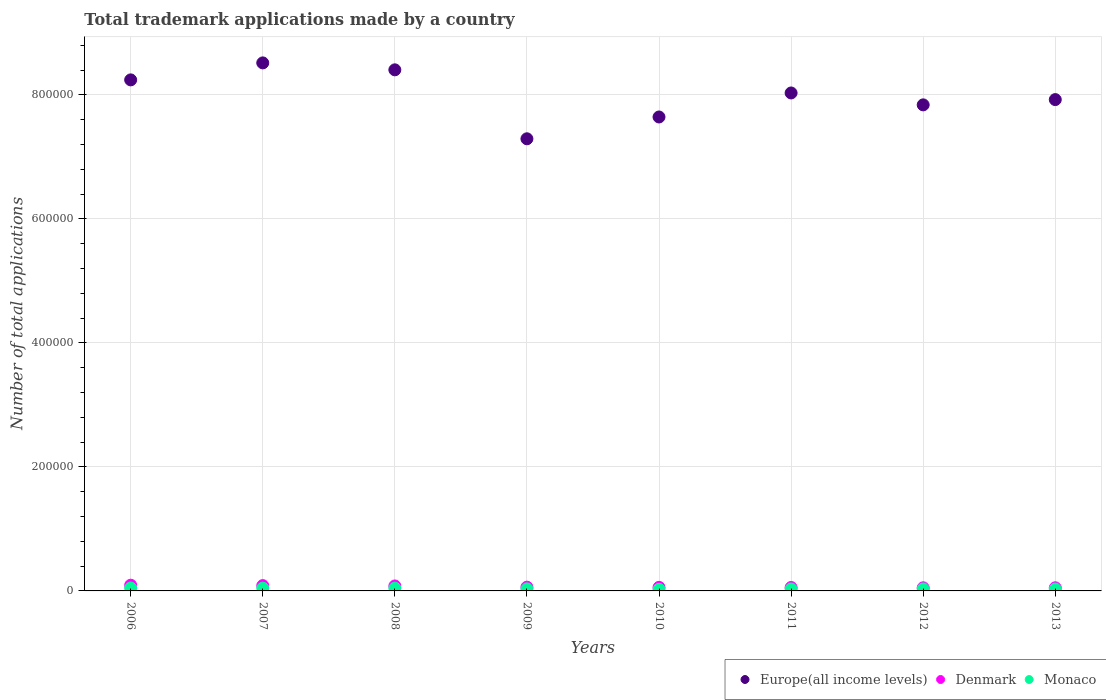How many different coloured dotlines are there?
Offer a very short reply. 3. What is the number of applications made by in Denmark in 2006?
Keep it short and to the point. 9226. Across all years, what is the maximum number of applications made by in Denmark?
Your answer should be compact. 9226. Across all years, what is the minimum number of applications made by in Monaco?
Offer a terse response. 2567. In which year was the number of applications made by in Europe(all income levels) minimum?
Give a very brief answer. 2009. What is the total number of applications made by in Denmark in the graph?
Provide a succinct answer. 5.33e+04. What is the difference between the number of applications made by in Denmark in 2006 and that in 2008?
Your answer should be compact. 1207. What is the difference between the number of applications made by in Denmark in 2006 and the number of applications made by in Europe(all income levels) in 2011?
Your response must be concise. -7.94e+05. What is the average number of applications made by in Monaco per year?
Provide a succinct answer. 3631.5. In the year 2007, what is the difference between the number of applications made by in Denmark and number of applications made by in Monaco?
Ensure brevity in your answer.  4170. In how many years, is the number of applications made by in Europe(all income levels) greater than 760000?
Your response must be concise. 7. What is the ratio of the number of applications made by in Monaco in 2008 to that in 2011?
Your answer should be very brief. 1.39. Is the difference between the number of applications made by in Denmark in 2011 and 2012 greater than the difference between the number of applications made by in Monaco in 2011 and 2012?
Provide a short and direct response. Yes. What is the difference between the highest and the second highest number of applications made by in Monaco?
Give a very brief answer. 175. What is the difference between the highest and the lowest number of applications made by in Europe(all income levels)?
Your answer should be compact. 1.22e+05. Is it the case that in every year, the sum of the number of applications made by in Europe(all income levels) and number of applications made by in Monaco  is greater than the number of applications made by in Denmark?
Offer a terse response. Yes. Are the values on the major ticks of Y-axis written in scientific E-notation?
Provide a short and direct response. No. Does the graph contain any zero values?
Offer a very short reply. No. Does the graph contain grids?
Provide a short and direct response. Yes. How many legend labels are there?
Your answer should be very brief. 3. What is the title of the graph?
Provide a succinct answer. Total trademark applications made by a country. What is the label or title of the X-axis?
Ensure brevity in your answer.  Years. What is the label or title of the Y-axis?
Provide a succinct answer. Number of total applications. What is the Number of total applications in Europe(all income levels) in 2006?
Provide a succinct answer. 8.24e+05. What is the Number of total applications of Denmark in 2006?
Offer a terse response. 9226. What is the Number of total applications in Monaco in 2006?
Provide a short and direct response. 4649. What is the Number of total applications in Europe(all income levels) in 2007?
Make the answer very short. 8.52e+05. What is the Number of total applications in Denmark in 2007?
Make the answer very short. 8583. What is the Number of total applications of Monaco in 2007?
Offer a terse response. 4413. What is the Number of total applications of Europe(all income levels) in 2008?
Provide a succinct answer. 8.40e+05. What is the Number of total applications in Denmark in 2008?
Your answer should be very brief. 8019. What is the Number of total applications of Monaco in 2008?
Offer a terse response. 4474. What is the Number of total applications of Europe(all income levels) in 2009?
Make the answer very short. 7.29e+05. What is the Number of total applications of Denmark in 2009?
Your answer should be very brief. 6075. What is the Number of total applications in Monaco in 2009?
Give a very brief answer. 3324. What is the Number of total applications in Europe(all income levels) in 2010?
Your answer should be compact. 7.64e+05. What is the Number of total applications of Denmark in 2010?
Ensure brevity in your answer.  5750. What is the Number of total applications in Monaco in 2010?
Provide a short and direct response. 2567. What is the Number of total applications of Europe(all income levels) in 2011?
Provide a succinct answer. 8.03e+05. What is the Number of total applications of Denmark in 2011?
Your response must be concise. 5549. What is the Number of total applications in Monaco in 2011?
Make the answer very short. 3212. What is the Number of total applications in Europe(all income levels) in 2012?
Provide a short and direct response. 7.84e+05. What is the Number of total applications in Denmark in 2012?
Give a very brief answer. 5032. What is the Number of total applications in Monaco in 2012?
Your answer should be very brief. 3264. What is the Number of total applications of Europe(all income levels) in 2013?
Provide a succinct answer. 7.92e+05. What is the Number of total applications of Denmark in 2013?
Provide a short and direct response. 5054. What is the Number of total applications of Monaco in 2013?
Keep it short and to the point. 3149. Across all years, what is the maximum Number of total applications in Europe(all income levels)?
Your answer should be compact. 8.52e+05. Across all years, what is the maximum Number of total applications in Denmark?
Make the answer very short. 9226. Across all years, what is the maximum Number of total applications of Monaco?
Keep it short and to the point. 4649. Across all years, what is the minimum Number of total applications in Europe(all income levels)?
Give a very brief answer. 7.29e+05. Across all years, what is the minimum Number of total applications of Denmark?
Make the answer very short. 5032. Across all years, what is the minimum Number of total applications in Monaco?
Your response must be concise. 2567. What is the total Number of total applications in Europe(all income levels) in the graph?
Your answer should be compact. 6.39e+06. What is the total Number of total applications in Denmark in the graph?
Give a very brief answer. 5.33e+04. What is the total Number of total applications in Monaco in the graph?
Give a very brief answer. 2.91e+04. What is the difference between the Number of total applications of Europe(all income levels) in 2006 and that in 2007?
Your answer should be compact. -2.74e+04. What is the difference between the Number of total applications of Denmark in 2006 and that in 2007?
Your answer should be very brief. 643. What is the difference between the Number of total applications of Monaco in 2006 and that in 2007?
Keep it short and to the point. 236. What is the difference between the Number of total applications in Europe(all income levels) in 2006 and that in 2008?
Provide a succinct answer. -1.62e+04. What is the difference between the Number of total applications in Denmark in 2006 and that in 2008?
Offer a very short reply. 1207. What is the difference between the Number of total applications in Monaco in 2006 and that in 2008?
Offer a very short reply. 175. What is the difference between the Number of total applications of Europe(all income levels) in 2006 and that in 2009?
Provide a short and direct response. 9.50e+04. What is the difference between the Number of total applications of Denmark in 2006 and that in 2009?
Ensure brevity in your answer.  3151. What is the difference between the Number of total applications of Monaco in 2006 and that in 2009?
Offer a very short reply. 1325. What is the difference between the Number of total applications in Europe(all income levels) in 2006 and that in 2010?
Your response must be concise. 5.98e+04. What is the difference between the Number of total applications in Denmark in 2006 and that in 2010?
Keep it short and to the point. 3476. What is the difference between the Number of total applications in Monaco in 2006 and that in 2010?
Provide a succinct answer. 2082. What is the difference between the Number of total applications in Europe(all income levels) in 2006 and that in 2011?
Give a very brief answer. 2.11e+04. What is the difference between the Number of total applications of Denmark in 2006 and that in 2011?
Ensure brevity in your answer.  3677. What is the difference between the Number of total applications in Monaco in 2006 and that in 2011?
Provide a succinct answer. 1437. What is the difference between the Number of total applications in Europe(all income levels) in 2006 and that in 2012?
Your answer should be compact. 4.03e+04. What is the difference between the Number of total applications in Denmark in 2006 and that in 2012?
Give a very brief answer. 4194. What is the difference between the Number of total applications of Monaco in 2006 and that in 2012?
Give a very brief answer. 1385. What is the difference between the Number of total applications in Europe(all income levels) in 2006 and that in 2013?
Offer a very short reply. 3.18e+04. What is the difference between the Number of total applications of Denmark in 2006 and that in 2013?
Your answer should be compact. 4172. What is the difference between the Number of total applications of Monaco in 2006 and that in 2013?
Keep it short and to the point. 1500. What is the difference between the Number of total applications of Europe(all income levels) in 2007 and that in 2008?
Your response must be concise. 1.12e+04. What is the difference between the Number of total applications of Denmark in 2007 and that in 2008?
Offer a terse response. 564. What is the difference between the Number of total applications in Monaco in 2007 and that in 2008?
Make the answer very short. -61. What is the difference between the Number of total applications in Europe(all income levels) in 2007 and that in 2009?
Provide a succinct answer. 1.22e+05. What is the difference between the Number of total applications in Denmark in 2007 and that in 2009?
Make the answer very short. 2508. What is the difference between the Number of total applications of Monaco in 2007 and that in 2009?
Provide a short and direct response. 1089. What is the difference between the Number of total applications of Europe(all income levels) in 2007 and that in 2010?
Your answer should be very brief. 8.72e+04. What is the difference between the Number of total applications of Denmark in 2007 and that in 2010?
Make the answer very short. 2833. What is the difference between the Number of total applications in Monaco in 2007 and that in 2010?
Provide a succinct answer. 1846. What is the difference between the Number of total applications in Europe(all income levels) in 2007 and that in 2011?
Ensure brevity in your answer.  4.85e+04. What is the difference between the Number of total applications of Denmark in 2007 and that in 2011?
Your response must be concise. 3034. What is the difference between the Number of total applications of Monaco in 2007 and that in 2011?
Your response must be concise. 1201. What is the difference between the Number of total applications in Europe(all income levels) in 2007 and that in 2012?
Your answer should be very brief. 6.77e+04. What is the difference between the Number of total applications in Denmark in 2007 and that in 2012?
Keep it short and to the point. 3551. What is the difference between the Number of total applications of Monaco in 2007 and that in 2012?
Provide a short and direct response. 1149. What is the difference between the Number of total applications of Europe(all income levels) in 2007 and that in 2013?
Keep it short and to the point. 5.92e+04. What is the difference between the Number of total applications in Denmark in 2007 and that in 2013?
Provide a succinct answer. 3529. What is the difference between the Number of total applications in Monaco in 2007 and that in 2013?
Provide a succinct answer. 1264. What is the difference between the Number of total applications of Europe(all income levels) in 2008 and that in 2009?
Your answer should be compact. 1.11e+05. What is the difference between the Number of total applications in Denmark in 2008 and that in 2009?
Give a very brief answer. 1944. What is the difference between the Number of total applications in Monaco in 2008 and that in 2009?
Make the answer very short. 1150. What is the difference between the Number of total applications of Europe(all income levels) in 2008 and that in 2010?
Give a very brief answer. 7.60e+04. What is the difference between the Number of total applications in Denmark in 2008 and that in 2010?
Offer a terse response. 2269. What is the difference between the Number of total applications of Monaco in 2008 and that in 2010?
Your answer should be compact. 1907. What is the difference between the Number of total applications in Europe(all income levels) in 2008 and that in 2011?
Provide a short and direct response. 3.73e+04. What is the difference between the Number of total applications of Denmark in 2008 and that in 2011?
Provide a short and direct response. 2470. What is the difference between the Number of total applications in Monaco in 2008 and that in 2011?
Give a very brief answer. 1262. What is the difference between the Number of total applications in Europe(all income levels) in 2008 and that in 2012?
Your answer should be very brief. 5.65e+04. What is the difference between the Number of total applications in Denmark in 2008 and that in 2012?
Make the answer very short. 2987. What is the difference between the Number of total applications of Monaco in 2008 and that in 2012?
Offer a terse response. 1210. What is the difference between the Number of total applications in Europe(all income levels) in 2008 and that in 2013?
Keep it short and to the point. 4.80e+04. What is the difference between the Number of total applications in Denmark in 2008 and that in 2013?
Offer a very short reply. 2965. What is the difference between the Number of total applications in Monaco in 2008 and that in 2013?
Provide a succinct answer. 1325. What is the difference between the Number of total applications in Europe(all income levels) in 2009 and that in 2010?
Ensure brevity in your answer.  -3.52e+04. What is the difference between the Number of total applications in Denmark in 2009 and that in 2010?
Keep it short and to the point. 325. What is the difference between the Number of total applications of Monaco in 2009 and that in 2010?
Ensure brevity in your answer.  757. What is the difference between the Number of total applications in Europe(all income levels) in 2009 and that in 2011?
Your answer should be very brief. -7.39e+04. What is the difference between the Number of total applications of Denmark in 2009 and that in 2011?
Give a very brief answer. 526. What is the difference between the Number of total applications in Monaco in 2009 and that in 2011?
Your response must be concise. 112. What is the difference between the Number of total applications in Europe(all income levels) in 2009 and that in 2012?
Your answer should be very brief. -5.47e+04. What is the difference between the Number of total applications of Denmark in 2009 and that in 2012?
Offer a terse response. 1043. What is the difference between the Number of total applications in Monaco in 2009 and that in 2012?
Make the answer very short. 60. What is the difference between the Number of total applications in Europe(all income levels) in 2009 and that in 2013?
Ensure brevity in your answer.  -6.32e+04. What is the difference between the Number of total applications in Denmark in 2009 and that in 2013?
Keep it short and to the point. 1021. What is the difference between the Number of total applications in Monaco in 2009 and that in 2013?
Your answer should be very brief. 175. What is the difference between the Number of total applications of Europe(all income levels) in 2010 and that in 2011?
Your answer should be very brief. -3.87e+04. What is the difference between the Number of total applications in Denmark in 2010 and that in 2011?
Provide a short and direct response. 201. What is the difference between the Number of total applications in Monaco in 2010 and that in 2011?
Make the answer very short. -645. What is the difference between the Number of total applications in Europe(all income levels) in 2010 and that in 2012?
Keep it short and to the point. -1.95e+04. What is the difference between the Number of total applications of Denmark in 2010 and that in 2012?
Offer a very short reply. 718. What is the difference between the Number of total applications of Monaco in 2010 and that in 2012?
Provide a succinct answer. -697. What is the difference between the Number of total applications of Europe(all income levels) in 2010 and that in 2013?
Ensure brevity in your answer.  -2.80e+04. What is the difference between the Number of total applications in Denmark in 2010 and that in 2013?
Give a very brief answer. 696. What is the difference between the Number of total applications of Monaco in 2010 and that in 2013?
Make the answer very short. -582. What is the difference between the Number of total applications of Europe(all income levels) in 2011 and that in 2012?
Give a very brief answer. 1.92e+04. What is the difference between the Number of total applications of Denmark in 2011 and that in 2012?
Ensure brevity in your answer.  517. What is the difference between the Number of total applications in Monaco in 2011 and that in 2012?
Provide a succinct answer. -52. What is the difference between the Number of total applications in Europe(all income levels) in 2011 and that in 2013?
Give a very brief answer. 1.07e+04. What is the difference between the Number of total applications in Denmark in 2011 and that in 2013?
Give a very brief answer. 495. What is the difference between the Number of total applications in Europe(all income levels) in 2012 and that in 2013?
Ensure brevity in your answer.  -8486. What is the difference between the Number of total applications of Denmark in 2012 and that in 2013?
Make the answer very short. -22. What is the difference between the Number of total applications in Monaco in 2012 and that in 2013?
Ensure brevity in your answer.  115. What is the difference between the Number of total applications in Europe(all income levels) in 2006 and the Number of total applications in Denmark in 2007?
Your answer should be very brief. 8.16e+05. What is the difference between the Number of total applications of Europe(all income levels) in 2006 and the Number of total applications of Monaco in 2007?
Offer a very short reply. 8.20e+05. What is the difference between the Number of total applications of Denmark in 2006 and the Number of total applications of Monaco in 2007?
Make the answer very short. 4813. What is the difference between the Number of total applications in Europe(all income levels) in 2006 and the Number of total applications in Denmark in 2008?
Offer a very short reply. 8.16e+05. What is the difference between the Number of total applications of Europe(all income levels) in 2006 and the Number of total applications of Monaco in 2008?
Give a very brief answer. 8.20e+05. What is the difference between the Number of total applications in Denmark in 2006 and the Number of total applications in Monaco in 2008?
Ensure brevity in your answer.  4752. What is the difference between the Number of total applications in Europe(all income levels) in 2006 and the Number of total applications in Denmark in 2009?
Offer a very short reply. 8.18e+05. What is the difference between the Number of total applications of Europe(all income levels) in 2006 and the Number of total applications of Monaco in 2009?
Keep it short and to the point. 8.21e+05. What is the difference between the Number of total applications of Denmark in 2006 and the Number of total applications of Monaco in 2009?
Provide a short and direct response. 5902. What is the difference between the Number of total applications in Europe(all income levels) in 2006 and the Number of total applications in Denmark in 2010?
Offer a very short reply. 8.19e+05. What is the difference between the Number of total applications of Europe(all income levels) in 2006 and the Number of total applications of Monaco in 2010?
Make the answer very short. 8.22e+05. What is the difference between the Number of total applications of Denmark in 2006 and the Number of total applications of Monaco in 2010?
Provide a succinct answer. 6659. What is the difference between the Number of total applications of Europe(all income levels) in 2006 and the Number of total applications of Denmark in 2011?
Your answer should be compact. 8.19e+05. What is the difference between the Number of total applications of Europe(all income levels) in 2006 and the Number of total applications of Monaco in 2011?
Offer a very short reply. 8.21e+05. What is the difference between the Number of total applications in Denmark in 2006 and the Number of total applications in Monaco in 2011?
Provide a succinct answer. 6014. What is the difference between the Number of total applications in Europe(all income levels) in 2006 and the Number of total applications in Denmark in 2012?
Provide a short and direct response. 8.19e+05. What is the difference between the Number of total applications in Europe(all income levels) in 2006 and the Number of total applications in Monaco in 2012?
Your response must be concise. 8.21e+05. What is the difference between the Number of total applications in Denmark in 2006 and the Number of total applications in Monaco in 2012?
Offer a terse response. 5962. What is the difference between the Number of total applications in Europe(all income levels) in 2006 and the Number of total applications in Denmark in 2013?
Make the answer very short. 8.19e+05. What is the difference between the Number of total applications of Europe(all income levels) in 2006 and the Number of total applications of Monaco in 2013?
Keep it short and to the point. 8.21e+05. What is the difference between the Number of total applications of Denmark in 2006 and the Number of total applications of Monaco in 2013?
Ensure brevity in your answer.  6077. What is the difference between the Number of total applications of Europe(all income levels) in 2007 and the Number of total applications of Denmark in 2008?
Offer a very short reply. 8.44e+05. What is the difference between the Number of total applications in Europe(all income levels) in 2007 and the Number of total applications in Monaco in 2008?
Your answer should be compact. 8.47e+05. What is the difference between the Number of total applications of Denmark in 2007 and the Number of total applications of Monaco in 2008?
Give a very brief answer. 4109. What is the difference between the Number of total applications of Europe(all income levels) in 2007 and the Number of total applications of Denmark in 2009?
Offer a very short reply. 8.46e+05. What is the difference between the Number of total applications of Europe(all income levels) in 2007 and the Number of total applications of Monaco in 2009?
Your answer should be compact. 8.48e+05. What is the difference between the Number of total applications of Denmark in 2007 and the Number of total applications of Monaco in 2009?
Your answer should be very brief. 5259. What is the difference between the Number of total applications of Europe(all income levels) in 2007 and the Number of total applications of Denmark in 2010?
Make the answer very short. 8.46e+05. What is the difference between the Number of total applications in Europe(all income levels) in 2007 and the Number of total applications in Monaco in 2010?
Your answer should be compact. 8.49e+05. What is the difference between the Number of total applications in Denmark in 2007 and the Number of total applications in Monaco in 2010?
Keep it short and to the point. 6016. What is the difference between the Number of total applications in Europe(all income levels) in 2007 and the Number of total applications in Denmark in 2011?
Make the answer very short. 8.46e+05. What is the difference between the Number of total applications in Europe(all income levels) in 2007 and the Number of total applications in Monaco in 2011?
Give a very brief answer. 8.48e+05. What is the difference between the Number of total applications in Denmark in 2007 and the Number of total applications in Monaco in 2011?
Make the answer very short. 5371. What is the difference between the Number of total applications in Europe(all income levels) in 2007 and the Number of total applications in Denmark in 2012?
Your answer should be compact. 8.47e+05. What is the difference between the Number of total applications of Europe(all income levels) in 2007 and the Number of total applications of Monaco in 2012?
Make the answer very short. 8.48e+05. What is the difference between the Number of total applications of Denmark in 2007 and the Number of total applications of Monaco in 2012?
Your response must be concise. 5319. What is the difference between the Number of total applications of Europe(all income levels) in 2007 and the Number of total applications of Denmark in 2013?
Keep it short and to the point. 8.47e+05. What is the difference between the Number of total applications of Europe(all income levels) in 2007 and the Number of total applications of Monaco in 2013?
Provide a succinct answer. 8.49e+05. What is the difference between the Number of total applications in Denmark in 2007 and the Number of total applications in Monaco in 2013?
Provide a short and direct response. 5434. What is the difference between the Number of total applications in Europe(all income levels) in 2008 and the Number of total applications in Denmark in 2009?
Provide a succinct answer. 8.34e+05. What is the difference between the Number of total applications in Europe(all income levels) in 2008 and the Number of total applications in Monaco in 2009?
Ensure brevity in your answer.  8.37e+05. What is the difference between the Number of total applications of Denmark in 2008 and the Number of total applications of Monaco in 2009?
Your answer should be very brief. 4695. What is the difference between the Number of total applications of Europe(all income levels) in 2008 and the Number of total applications of Denmark in 2010?
Your answer should be very brief. 8.35e+05. What is the difference between the Number of total applications of Europe(all income levels) in 2008 and the Number of total applications of Monaco in 2010?
Give a very brief answer. 8.38e+05. What is the difference between the Number of total applications in Denmark in 2008 and the Number of total applications in Monaco in 2010?
Provide a succinct answer. 5452. What is the difference between the Number of total applications of Europe(all income levels) in 2008 and the Number of total applications of Denmark in 2011?
Make the answer very short. 8.35e+05. What is the difference between the Number of total applications in Europe(all income levels) in 2008 and the Number of total applications in Monaco in 2011?
Provide a short and direct response. 8.37e+05. What is the difference between the Number of total applications in Denmark in 2008 and the Number of total applications in Monaco in 2011?
Make the answer very short. 4807. What is the difference between the Number of total applications in Europe(all income levels) in 2008 and the Number of total applications in Denmark in 2012?
Offer a very short reply. 8.35e+05. What is the difference between the Number of total applications in Europe(all income levels) in 2008 and the Number of total applications in Monaco in 2012?
Provide a short and direct response. 8.37e+05. What is the difference between the Number of total applications in Denmark in 2008 and the Number of total applications in Monaco in 2012?
Give a very brief answer. 4755. What is the difference between the Number of total applications of Europe(all income levels) in 2008 and the Number of total applications of Denmark in 2013?
Provide a succinct answer. 8.35e+05. What is the difference between the Number of total applications of Europe(all income levels) in 2008 and the Number of total applications of Monaco in 2013?
Your answer should be very brief. 8.37e+05. What is the difference between the Number of total applications of Denmark in 2008 and the Number of total applications of Monaco in 2013?
Make the answer very short. 4870. What is the difference between the Number of total applications of Europe(all income levels) in 2009 and the Number of total applications of Denmark in 2010?
Provide a short and direct response. 7.24e+05. What is the difference between the Number of total applications in Europe(all income levels) in 2009 and the Number of total applications in Monaco in 2010?
Ensure brevity in your answer.  7.27e+05. What is the difference between the Number of total applications of Denmark in 2009 and the Number of total applications of Monaco in 2010?
Make the answer very short. 3508. What is the difference between the Number of total applications of Europe(all income levels) in 2009 and the Number of total applications of Denmark in 2011?
Your answer should be compact. 7.24e+05. What is the difference between the Number of total applications of Europe(all income levels) in 2009 and the Number of total applications of Monaco in 2011?
Offer a terse response. 7.26e+05. What is the difference between the Number of total applications in Denmark in 2009 and the Number of total applications in Monaco in 2011?
Your response must be concise. 2863. What is the difference between the Number of total applications of Europe(all income levels) in 2009 and the Number of total applications of Denmark in 2012?
Your response must be concise. 7.24e+05. What is the difference between the Number of total applications of Europe(all income levels) in 2009 and the Number of total applications of Monaco in 2012?
Your response must be concise. 7.26e+05. What is the difference between the Number of total applications in Denmark in 2009 and the Number of total applications in Monaco in 2012?
Your response must be concise. 2811. What is the difference between the Number of total applications of Europe(all income levels) in 2009 and the Number of total applications of Denmark in 2013?
Provide a short and direct response. 7.24e+05. What is the difference between the Number of total applications of Europe(all income levels) in 2009 and the Number of total applications of Monaco in 2013?
Provide a succinct answer. 7.26e+05. What is the difference between the Number of total applications of Denmark in 2009 and the Number of total applications of Monaco in 2013?
Offer a very short reply. 2926. What is the difference between the Number of total applications in Europe(all income levels) in 2010 and the Number of total applications in Denmark in 2011?
Provide a short and direct response. 7.59e+05. What is the difference between the Number of total applications in Europe(all income levels) in 2010 and the Number of total applications in Monaco in 2011?
Make the answer very short. 7.61e+05. What is the difference between the Number of total applications in Denmark in 2010 and the Number of total applications in Monaco in 2011?
Provide a short and direct response. 2538. What is the difference between the Number of total applications of Europe(all income levels) in 2010 and the Number of total applications of Denmark in 2012?
Make the answer very short. 7.59e+05. What is the difference between the Number of total applications of Europe(all income levels) in 2010 and the Number of total applications of Monaco in 2012?
Offer a terse response. 7.61e+05. What is the difference between the Number of total applications in Denmark in 2010 and the Number of total applications in Monaco in 2012?
Your answer should be compact. 2486. What is the difference between the Number of total applications in Europe(all income levels) in 2010 and the Number of total applications in Denmark in 2013?
Offer a very short reply. 7.59e+05. What is the difference between the Number of total applications in Europe(all income levels) in 2010 and the Number of total applications in Monaco in 2013?
Your answer should be compact. 7.61e+05. What is the difference between the Number of total applications in Denmark in 2010 and the Number of total applications in Monaco in 2013?
Give a very brief answer. 2601. What is the difference between the Number of total applications in Europe(all income levels) in 2011 and the Number of total applications in Denmark in 2012?
Make the answer very short. 7.98e+05. What is the difference between the Number of total applications in Europe(all income levels) in 2011 and the Number of total applications in Monaco in 2012?
Make the answer very short. 8.00e+05. What is the difference between the Number of total applications of Denmark in 2011 and the Number of total applications of Monaco in 2012?
Your answer should be very brief. 2285. What is the difference between the Number of total applications in Europe(all income levels) in 2011 and the Number of total applications in Denmark in 2013?
Make the answer very short. 7.98e+05. What is the difference between the Number of total applications of Europe(all income levels) in 2011 and the Number of total applications of Monaco in 2013?
Offer a terse response. 8.00e+05. What is the difference between the Number of total applications of Denmark in 2011 and the Number of total applications of Monaco in 2013?
Your answer should be very brief. 2400. What is the difference between the Number of total applications in Europe(all income levels) in 2012 and the Number of total applications in Denmark in 2013?
Give a very brief answer. 7.79e+05. What is the difference between the Number of total applications of Europe(all income levels) in 2012 and the Number of total applications of Monaco in 2013?
Your answer should be compact. 7.81e+05. What is the difference between the Number of total applications of Denmark in 2012 and the Number of total applications of Monaco in 2013?
Offer a terse response. 1883. What is the average Number of total applications of Europe(all income levels) per year?
Offer a very short reply. 7.99e+05. What is the average Number of total applications of Denmark per year?
Your answer should be very brief. 6661. What is the average Number of total applications in Monaco per year?
Your answer should be very brief. 3631.5. In the year 2006, what is the difference between the Number of total applications in Europe(all income levels) and Number of total applications in Denmark?
Provide a succinct answer. 8.15e+05. In the year 2006, what is the difference between the Number of total applications in Europe(all income levels) and Number of total applications in Monaco?
Offer a very short reply. 8.20e+05. In the year 2006, what is the difference between the Number of total applications in Denmark and Number of total applications in Monaco?
Your response must be concise. 4577. In the year 2007, what is the difference between the Number of total applications of Europe(all income levels) and Number of total applications of Denmark?
Provide a succinct answer. 8.43e+05. In the year 2007, what is the difference between the Number of total applications in Europe(all income levels) and Number of total applications in Monaco?
Your answer should be very brief. 8.47e+05. In the year 2007, what is the difference between the Number of total applications in Denmark and Number of total applications in Monaco?
Ensure brevity in your answer.  4170. In the year 2008, what is the difference between the Number of total applications of Europe(all income levels) and Number of total applications of Denmark?
Ensure brevity in your answer.  8.32e+05. In the year 2008, what is the difference between the Number of total applications in Europe(all income levels) and Number of total applications in Monaco?
Your answer should be very brief. 8.36e+05. In the year 2008, what is the difference between the Number of total applications of Denmark and Number of total applications of Monaco?
Provide a succinct answer. 3545. In the year 2009, what is the difference between the Number of total applications in Europe(all income levels) and Number of total applications in Denmark?
Your answer should be compact. 7.23e+05. In the year 2009, what is the difference between the Number of total applications of Europe(all income levels) and Number of total applications of Monaco?
Offer a terse response. 7.26e+05. In the year 2009, what is the difference between the Number of total applications of Denmark and Number of total applications of Monaco?
Provide a short and direct response. 2751. In the year 2010, what is the difference between the Number of total applications of Europe(all income levels) and Number of total applications of Denmark?
Your response must be concise. 7.59e+05. In the year 2010, what is the difference between the Number of total applications of Europe(all income levels) and Number of total applications of Monaco?
Ensure brevity in your answer.  7.62e+05. In the year 2010, what is the difference between the Number of total applications in Denmark and Number of total applications in Monaco?
Your answer should be very brief. 3183. In the year 2011, what is the difference between the Number of total applications of Europe(all income levels) and Number of total applications of Denmark?
Ensure brevity in your answer.  7.98e+05. In the year 2011, what is the difference between the Number of total applications of Europe(all income levels) and Number of total applications of Monaco?
Your response must be concise. 8.00e+05. In the year 2011, what is the difference between the Number of total applications in Denmark and Number of total applications in Monaco?
Your response must be concise. 2337. In the year 2012, what is the difference between the Number of total applications of Europe(all income levels) and Number of total applications of Denmark?
Ensure brevity in your answer.  7.79e+05. In the year 2012, what is the difference between the Number of total applications of Europe(all income levels) and Number of total applications of Monaco?
Provide a short and direct response. 7.81e+05. In the year 2012, what is the difference between the Number of total applications in Denmark and Number of total applications in Monaco?
Your response must be concise. 1768. In the year 2013, what is the difference between the Number of total applications of Europe(all income levels) and Number of total applications of Denmark?
Your response must be concise. 7.87e+05. In the year 2013, what is the difference between the Number of total applications of Europe(all income levels) and Number of total applications of Monaco?
Your answer should be compact. 7.89e+05. In the year 2013, what is the difference between the Number of total applications in Denmark and Number of total applications in Monaco?
Provide a succinct answer. 1905. What is the ratio of the Number of total applications in Europe(all income levels) in 2006 to that in 2007?
Give a very brief answer. 0.97. What is the ratio of the Number of total applications of Denmark in 2006 to that in 2007?
Keep it short and to the point. 1.07. What is the ratio of the Number of total applications in Monaco in 2006 to that in 2007?
Provide a succinct answer. 1.05. What is the ratio of the Number of total applications of Europe(all income levels) in 2006 to that in 2008?
Offer a very short reply. 0.98. What is the ratio of the Number of total applications in Denmark in 2006 to that in 2008?
Give a very brief answer. 1.15. What is the ratio of the Number of total applications in Monaco in 2006 to that in 2008?
Provide a short and direct response. 1.04. What is the ratio of the Number of total applications of Europe(all income levels) in 2006 to that in 2009?
Keep it short and to the point. 1.13. What is the ratio of the Number of total applications in Denmark in 2006 to that in 2009?
Give a very brief answer. 1.52. What is the ratio of the Number of total applications in Monaco in 2006 to that in 2009?
Your answer should be very brief. 1.4. What is the ratio of the Number of total applications of Europe(all income levels) in 2006 to that in 2010?
Give a very brief answer. 1.08. What is the ratio of the Number of total applications in Denmark in 2006 to that in 2010?
Offer a terse response. 1.6. What is the ratio of the Number of total applications in Monaco in 2006 to that in 2010?
Provide a short and direct response. 1.81. What is the ratio of the Number of total applications of Europe(all income levels) in 2006 to that in 2011?
Provide a short and direct response. 1.03. What is the ratio of the Number of total applications in Denmark in 2006 to that in 2011?
Ensure brevity in your answer.  1.66. What is the ratio of the Number of total applications of Monaco in 2006 to that in 2011?
Make the answer very short. 1.45. What is the ratio of the Number of total applications of Europe(all income levels) in 2006 to that in 2012?
Make the answer very short. 1.05. What is the ratio of the Number of total applications of Denmark in 2006 to that in 2012?
Make the answer very short. 1.83. What is the ratio of the Number of total applications of Monaco in 2006 to that in 2012?
Make the answer very short. 1.42. What is the ratio of the Number of total applications in Europe(all income levels) in 2006 to that in 2013?
Provide a short and direct response. 1.04. What is the ratio of the Number of total applications of Denmark in 2006 to that in 2013?
Provide a short and direct response. 1.83. What is the ratio of the Number of total applications in Monaco in 2006 to that in 2013?
Give a very brief answer. 1.48. What is the ratio of the Number of total applications of Europe(all income levels) in 2007 to that in 2008?
Keep it short and to the point. 1.01. What is the ratio of the Number of total applications of Denmark in 2007 to that in 2008?
Keep it short and to the point. 1.07. What is the ratio of the Number of total applications of Monaco in 2007 to that in 2008?
Ensure brevity in your answer.  0.99. What is the ratio of the Number of total applications of Europe(all income levels) in 2007 to that in 2009?
Provide a short and direct response. 1.17. What is the ratio of the Number of total applications of Denmark in 2007 to that in 2009?
Your answer should be very brief. 1.41. What is the ratio of the Number of total applications of Monaco in 2007 to that in 2009?
Give a very brief answer. 1.33. What is the ratio of the Number of total applications of Europe(all income levels) in 2007 to that in 2010?
Make the answer very short. 1.11. What is the ratio of the Number of total applications in Denmark in 2007 to that in 2010?
Provide a short and direct response. 1.49. What is the ratio of the Number of total applications of Monaco in 2007 to that in 2010?
Your answer should be compact. 1.72. What is the ratio of the Number of total applications of Europe(all income levels) in 2007 to that in 2011?
Make the answer very short. 1.06. What is the ratio of the Number of total applications of Denmark in 2007 to that in 2011?
Provide a succinct answer. 1.55. What is the ratio of the Number of total applications of Monaco in 2007 to that in 2011?
Your answer should be very brief. 1.37. What is the ratio of the Number of total applications in Europe(all income levels) in 2007 to that in 2012?
Your response must be concise. 1.09. What is the ratio of the Number of total applications in Denmark in 2007 to that in 2012?
Offer a very short reply. 1.71. What is the ratio of the Number of total applications in Monaco in 2007 to that in 2012?
Your answer should be compact. 1.35. What is the ratio of the Number of total applications of Europe(all income levels) in 2007 to that in 2013?
Keep it short and to the point. 1.07. What is the ratio of the Number of total applications of Denmark in 2007 to that in 2013?
Your response must be concise. 1.7. What is the ratio of the Number of total applications in Monaco in 2007 to that in 2013?
Offer a very short reply. 1.4. What is the ratio of the Number of total applications of Europe(all income levels) in 2008 to that in 2009?
Make the answer very short. 1.15. What is the ratio of the Number of total applications in Denmark in 2008 to that in 2009?
Your answer should be compact. 1.32. What is the ratio of the Number of total applications of Monaco in 2008 to that in 2009?
Provide a succinct answer. 1.35. What is the ratio of the Number of total applications of Europe(all income levels) in 2008 to that in 2010?
Your answer should be compact. 1.1. What is the ratio of the Number of total applications in Denmark in 2008 to that in 2010?
Give a very brief answer. 1.39. What is the ratio of the Number of total applications in Monaco in 2008 to that in 2010?
Offer a very short reply. 1.74. What is the ratio of the Number of total applications of Europe(all income levels) in 2008 to that in 2011?
Give a very brief answer. 1.05. What is the ratio of the Number of total applications of Denmark in 2008 to that in 2011?
Offer a terse response. 1.45. What is the ratio of the Number of total applications in Monaco in 2008 to that in 2011?
Ensure brevity in your answer.  1.39. What is the ratio of the Number of total applications of Europe(all income levels) in 2008 to that in 2012?
Offer a terse response. 1.07. What is the ratio of the Number of total applications of Denmark in 2008 to that in 2012?
Ensure brevity in your answer.  1.59. What is the ratio of the Number of total applications of Monaco in 2008 to that in 2012?
Keep it short and to the point. 1.37. What is the ratio of the Number of total applications in Europe(all income levels) in 2008 to that in 2013?
Your response must be concise. 1.06. What is the ratio of the Number of total applications of Denmark in 2008 to that in 2013?
Your answer should be compact. 1.59. What is the ratio of the Number of total applications in Monaco in 2008 to that in 2013?
Give a very brief answer. 1.42. What is the ratio of the Number of total applications in Europe(all income levels) in 2009 to that in 2010?
Offer a very short reply. 0.95. What is the ratio of the Number of total applications in Denmark in 2009 to that in 2010?
Provide a succinct answer. 1.06. What is the ratio of the Number of total applications of Monaco in 2009 to that in 2010?
Offer a terse response. 1.29. What is the ratio of the Number of total applications in Europe(all income levels) in 2009 to that in 2011?
Offer a terse response. 0.91. What is the ratio of the Number of total applications in Denmark in 2009 to that in 2011?
Ensure brevity in your answer.  1.09. What is the ratio of the Number of total applications of Monaco in 2009 to that in 2011?
Provide a succinct answer. 1.03. What is the ratio of the Number of total applications of Europe(all income levels) in 2009 to that in 2012?
Make the answer very short. 0.93. What is the ratio of the Number of total applications of Denmark in 2009 to that in 2012?
Offer a very short reply. 1.21. What is the ratio of the Number of total applications in Monaco in 2009 to that in 2012?
Offer a very short reply. 1.02. What is the ratio of the Number of total applications of Europe(all income levels) in 2009 to that in 2013?
Your answer should be very brief. 0.92. What is the ratio of the Number of total applications of Denmark in 2009 to that in 2013?
Provide a short and direct response. 1.2. What is the ratio of the Number of total applications of Monaco in 2009 to that in 2013?
Give a very brief answer. 1.06. What is the ratio of the Number of total applications in Europe(all income levels) in 2010 to that in 2011?
Provide a succinct answer. 0.95. What is the ratio of the Number of total applications of Denmark in 2010 to that in 2011?
Provide a succinct answer. 1.04. What is the ratio of the Number of total applications of Monaco in 2010 to that in 2011?
Give a very brief answer. 0.8. What is the ratio of the Number of total applications of Europe(all income levels) in 2010 to that in 2012?
Keep it short and to the point. 0.98. What is the ratio of the Number of total applications of Denmark in 2010 to that in 2012?
Make the answer very short. 1.14. What is the ratio of the Number of total applications of Monaco in 2010 to that in 2012?
Keep it short and to the point. 0.79. What is the ratio of the Number of total applications of Europe(all income levels) in 2010 to that in 2013?
Give a very brief answer. 0.96. What is the ratio of the Number of total applications of Denmark in 2010 to that in 2013?
Offer a terse response. 1.14. What is the ratio of the Number of total applications in Monaco in 2010 to that in 2013?
Offer a terse response. 0.82. What is the ratio of the Number of total applications of Europe(all income levels) in 2011 to that in 2012?
Give a very brief answer. 1.02. What is the ratio of the Number of total applications in Denmark in 2011 to that in 2012?
Ensure brevity in your answer.  1.1. What is the ratio of the Number of total applications of Monaco in 2011 to that in 2012?
Your answer should be compact. 0.98. What is the ratio of the Number of total applications in Europe(all income levels) in 2011 to that in 2013?
Keep it short and to the point. 1.01. What is the ratio of the Number of total applications in Denmark in 2011 to that in 2013?
Your response must be concise. 1.1. What is the ratio of the Number of total applications in Europe(all income levels) in 2012 to that in 2013?
Your response must be concise. 0.99. What is the ratio of the Number of total applications of Monaco in 2012 to that in 2013?
Your answer should be very brief. 1.04. What is the difference between the highest and the second highest Number of total applications in Europe(all income levels)?
Your answer should be very brief. 1.12e+04. What is the difference between the highest and the second highest Number of total applications of Denmark?
Make the answer very short. 643. What is the difference between the highest and the second highest Number of total applications in Monaco?
Make the answer very short. 175. What is the difference between the highest and the lowest Number of total applications of Europe(all income levels)?
Make the answer very short. 1.22e+05. What is the difference between the highest and the lowest Number of total applications in Denmark?
Provide a succinct answer. 4194. What is the difference between the highest and the lowest Number of total applications in Monaco?
Keep it short and to the point. 2082. 